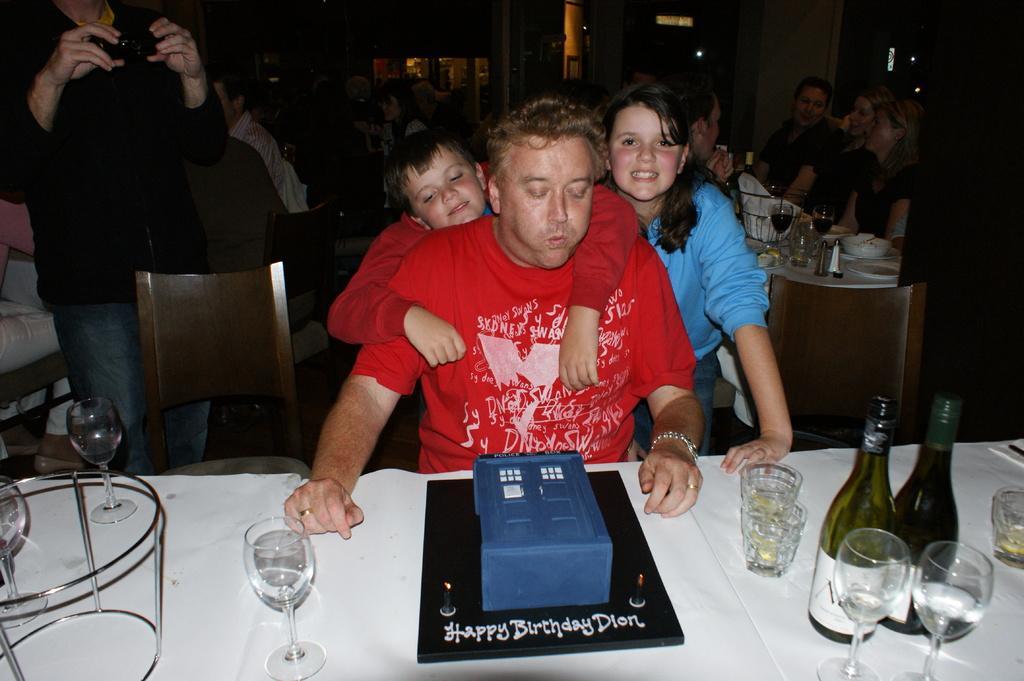Can you describe this image briefly? In this image there are people sitting on the chairs at the tables. At the bottom there is a table. On the table there are wine glasses, wine bottles, glasses and a cake. There is text on the cake. Beside the table there is a man sitting on the chair. Behind the man there are two kids. To the left there is a person standing and holding a camera in the hand. The background is dark. 